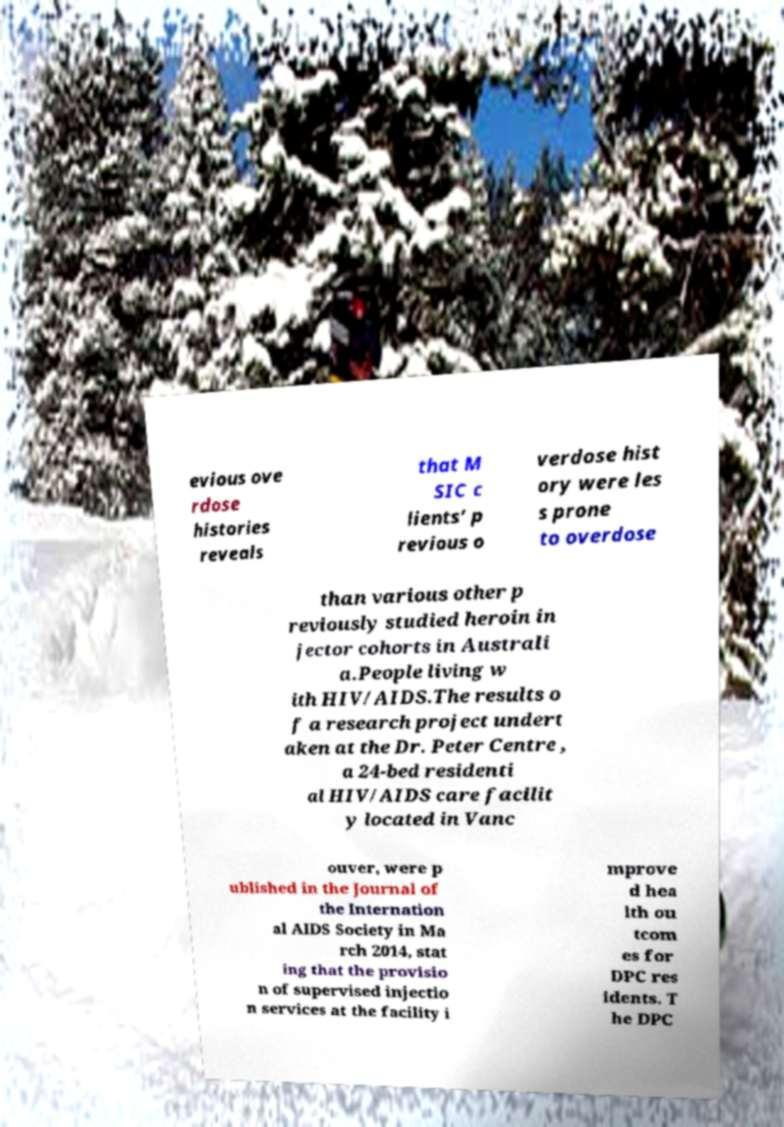For documentation purposes, I need the text within this image transcribed. Could you provide that? evious ove rdose histories reveals that M SIC c lients’ p revious o verdose hist ory were les s prone to overdose than various other p reviously studied heroin in jector cohorts in Australi a.People living w ith HIV/AIDS.The results o f a research project undert aken at the Dr. Peter Centre , a 24-bed residenti al HIV/AIDS care facilit y located in Vanc ouver, were p ublished in the Journal of the Internation al AIDS Society in Ma rch 2014, stat ing that the provisio n of supervised injectio n services at the facility i mprove d hea lth ou tcom es for DPC res idents. T he DPC 